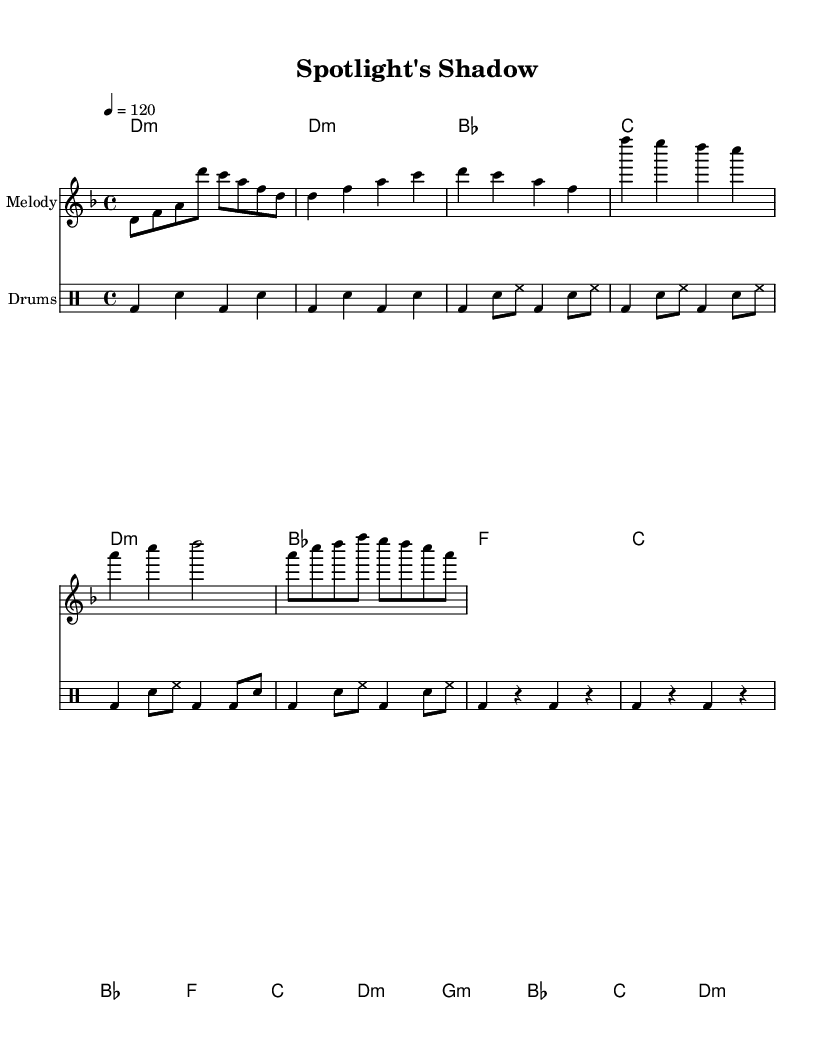What is the key signature of this music? The key signature is D minor, which has one flat (B flat) in the scale. This can be identified by looking at the key signature symbol at the beginning of the sheet music on the staff.
Answer: D minor What is the time signature of this music? The time signature is 4/4, which indicates there are four beats in each measure and the quarter note gets one beat. This is shown at the beginning of the sheet music next to the key signature.
Answer: 4/4 What is the tempo marking for this piece? The tempo marking is quarter note equals 120 beats per minute. This is written at the beginning of the score, indicating how fast the piece should be played.
Answer: 120 How many measures are in the verse section? There are a total of four measures in the verse section of the music. This can be counted in the melody and harmonies, where the verse measures are explicitly shown.
Answer: 4 What is the primary theme expressed in the lyrics? The primary theme expressed in the lyrics revolves around the struggles and darker sides of fame. By analyzing the lyrics provided, phrases like "Fame's a drug" and "Smile for the crowd, hide the pain" illustrate this theme.
Answer: Fame's darker side Which part of the score features significant instrumental emphasis? The chorus section features significant instrumental emphasis, as it is where the melody and harmonies come together powerfully, accompanied by the drums that intensify the dynamics. This is apparent when analyzing the musical structure and dynamics in that section.
Answer: Chorus 